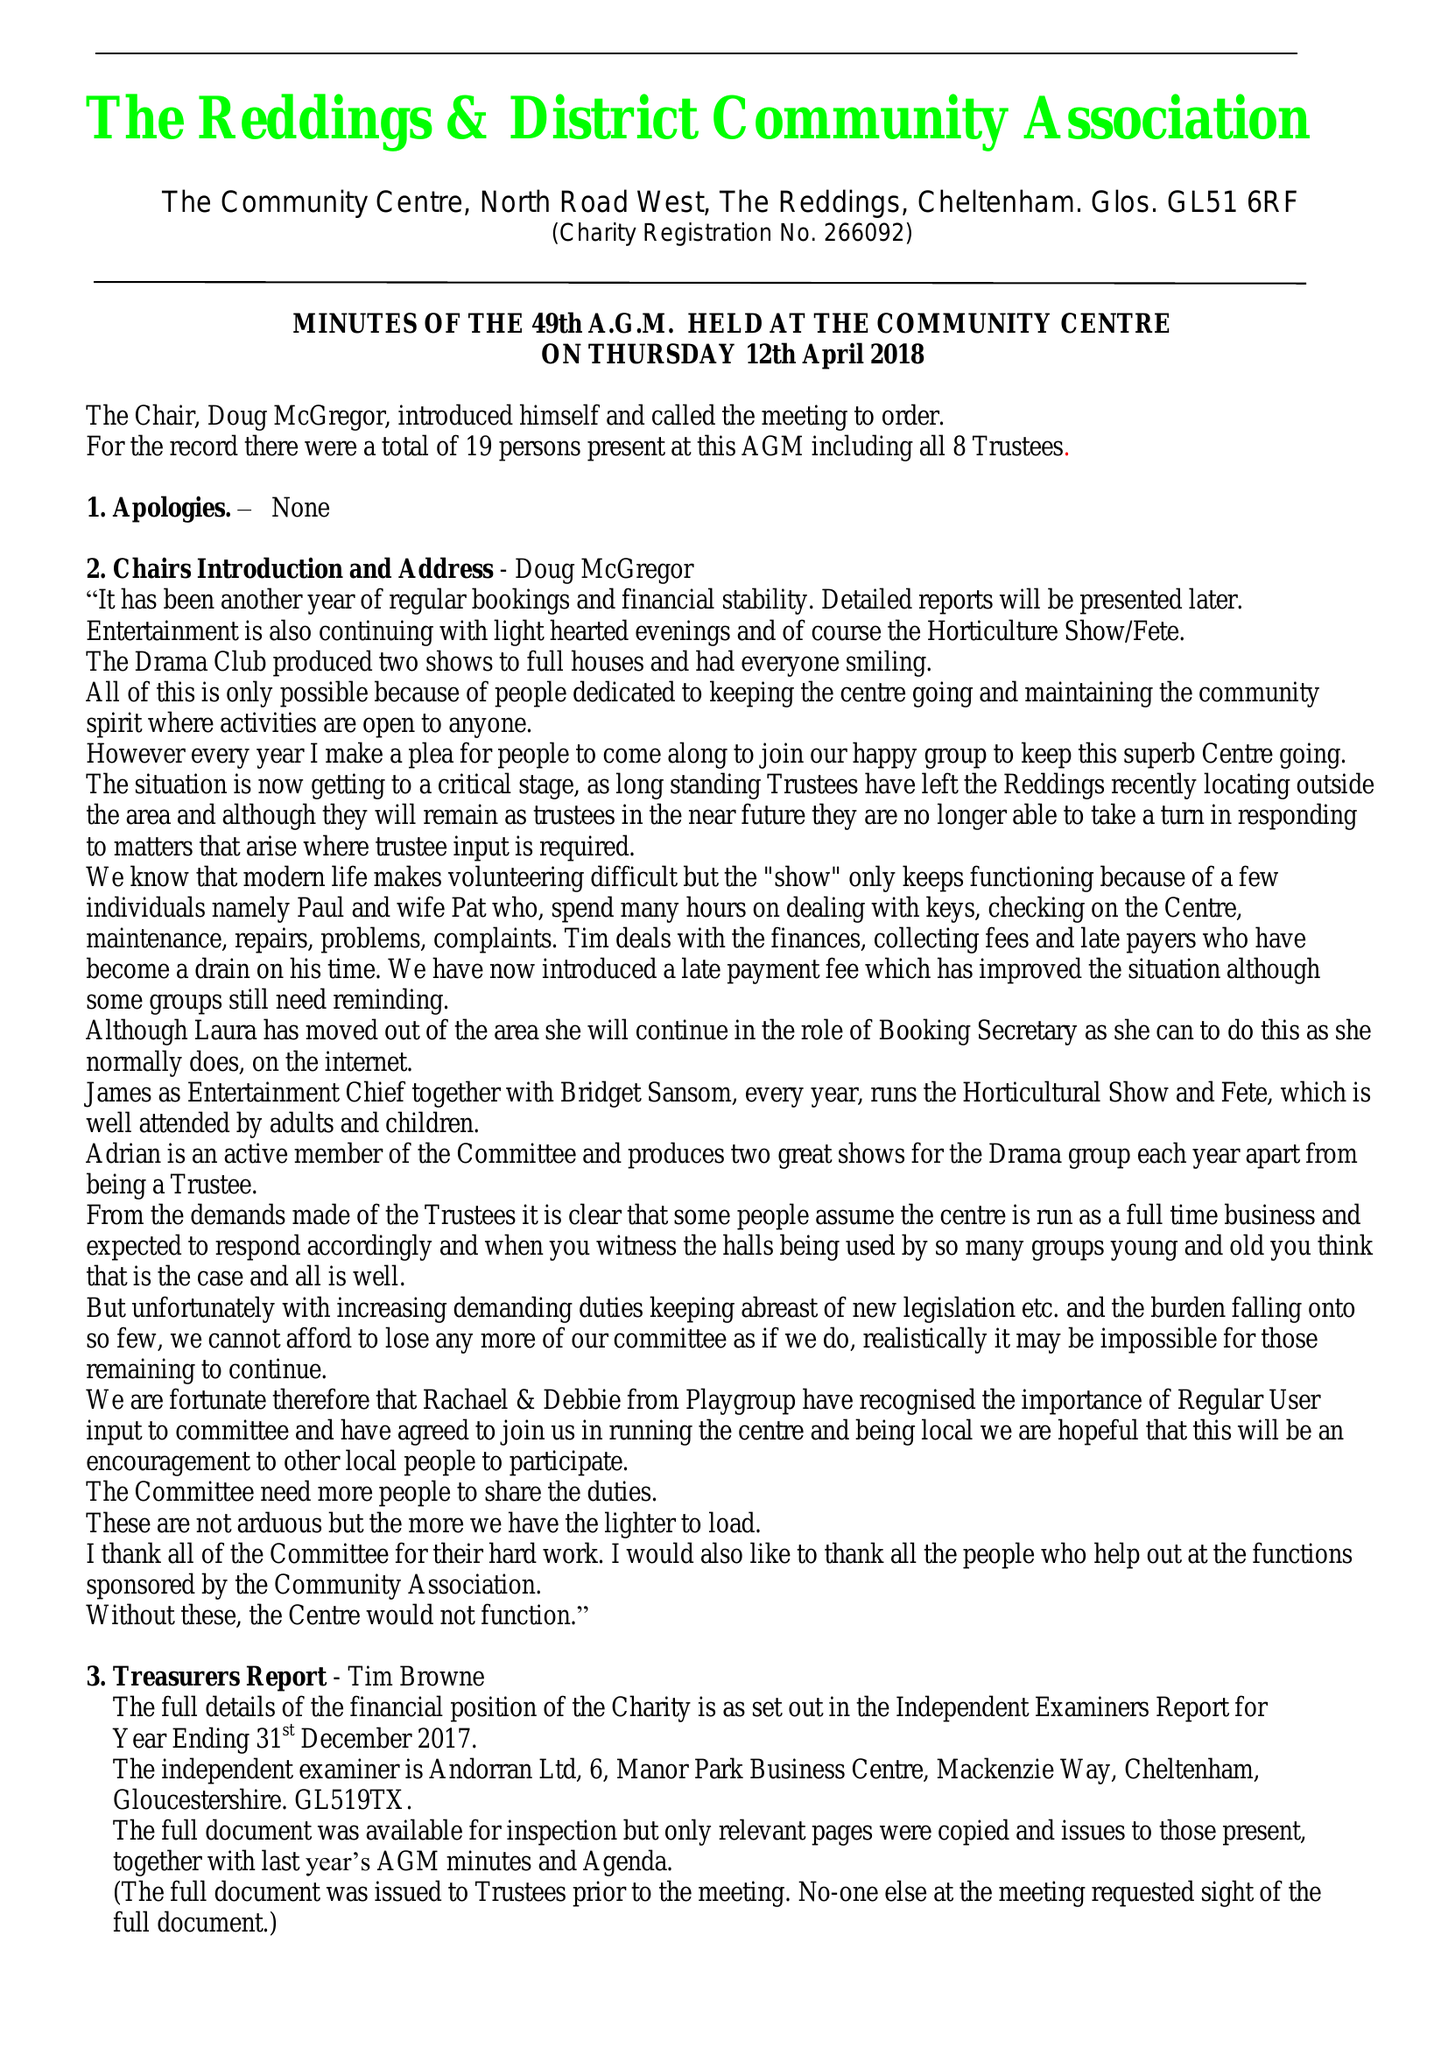What is the value for the address__street_line?
Answer the question using a single word or phrase. NORTH ROAD WEST 